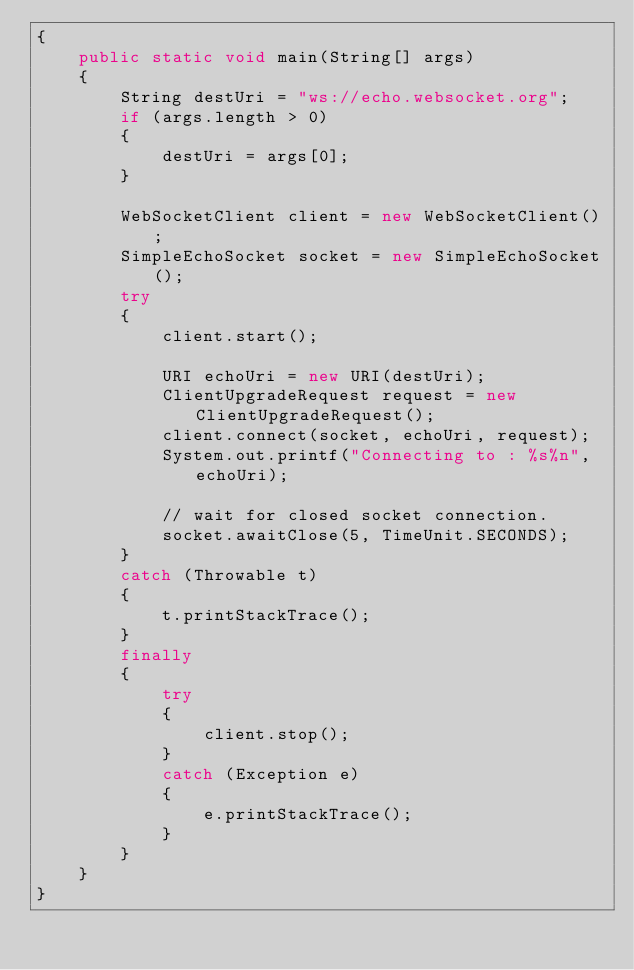<code> <loc_0><loc_0><loc_500><loc_500><_Java_>{
    public static void main(String[] args)
    {
        String destUri = "ws://echo.websocket.org";
        if (args.length > 0)
        {
            destUri = args[0];
        }

        WebSocketClient client = new WebSocketClient();
        SimpleEchoSocket socket = new SimpleEchoSocket();
        try
        {
            client.start();

            URI echoUri = new URI(destUri);
            ClientUpgradeRequest request = new ClientUpgradeRequest();
            client.connect(socket, echoUri, request);
            System.out.printf("Connecting to : %s%n", echoUri);

            // wait for closed socket connection.
            socket.awaitClose(5, TimeUnit.SECONDS);
        }
        catch (Throwable t)
        {
            t.printStackTrace();
        }
        finally
        {
            try
            {
                client.stop();
            }
            catch (Exception e)
            {
                e.printStackTrace();
            }
        }
    }
}
</code> 